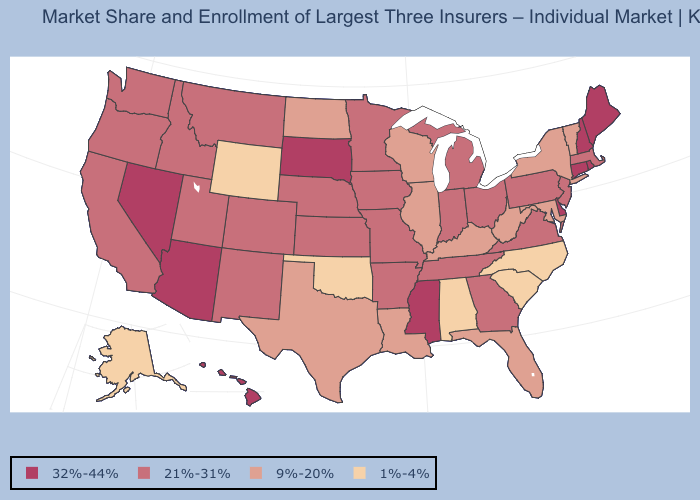Does the map have missing data?
Short answer required. No. What is the value of Wisconsin?
Keep it brief. 9%-20%. What is the value of New Jersey?
Short answer required. 21%-31%. Name the states that have a value in the range 32%-44%?
Answer briefly. Arizona, Connecticut, Delaware, Hawaii, Maine, Mississippi, Nevada, New Hampshire, Rhode Island, South Dakota. What is the lowest value in states that border Delaware?
Concise answer only. 9%-20%. Does the map have missing data?
Answer briefly. No. Which states have the highest value in the USA?
Give a very brief answer. Arizona, Connecticut, Delaware, Hawaii, Maine, Mississippi, Nevada, New Hampshire, Rhode Island, South Dakota. How many symbols are there in the legend?
Short answer required. 4. Name the states that have a value in the range 9%-20%?
Keep it brief. Florida, Illinois, Kentucky, Louisiana, Maryland, New York, North Dakota, Texas, Vermont, West Virginia, Wisconsin. Which states hav the highest value in the Northeast?
Answer briefly. Connecticut, Maine, New Hampshire, Rhode Island. What is the value of South Dakota?
Short answer required. 32%-44%. Among the states that border Utah , which have the highest value?
Give a very brief answer. Arizona, Nevada. What is the value of Nevada?
Quick response, please. 32%-44%. Does Kansas have the lowest value in the MidWest?
Concise answer only. No. What is the lowest value in the South?
Short answer required. 1%-4%. 